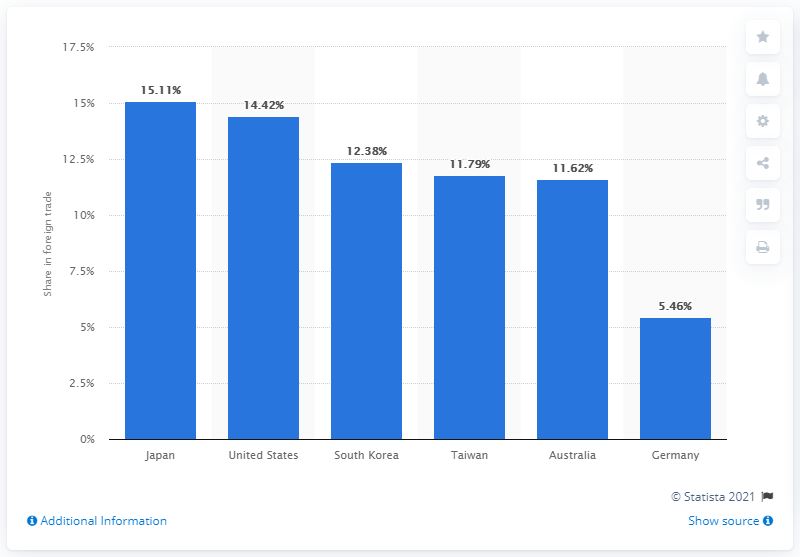Highlight a few significant elements in this photo. In 2013, China accounted for 5.46% of Germany's total foreign trade. 